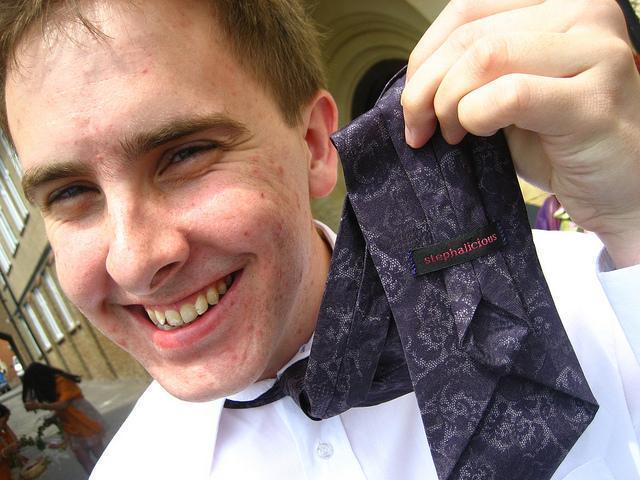How many people in the shot?
Give a very brief answer. 1. How many ties are there?
Give a very brief answer. 1. How many people are there?
Give a very brief answer. 2. How many giraffes are there?
Give a very brief answer. 0. 